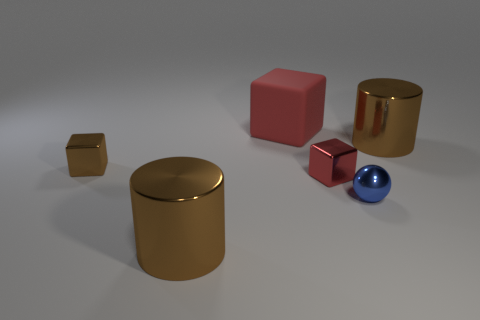Subtract all big red matte cubes. How many cubes are left? 2 Add 2 big matte things. How many objects exist? 8 Subtract all cylinders. How many objects are left? 4 Subtract all blue cylinders. How many red cubes are left? 2 Subtract all brown blocks. How many blocks are left? 2 Subtract 0 red cylinders. How many objects are left? 6 Subtract 2 cubes. How many cubes are left? 1 Subtract all yellow cylinders. Subtract all cyan balls. How many cylinders are left? 2 Subtract all large matte cubes. Subtract all metal cylinders. How many objects are left? 3 Add 1 metal cubes. How many metal cubes are left? 3 